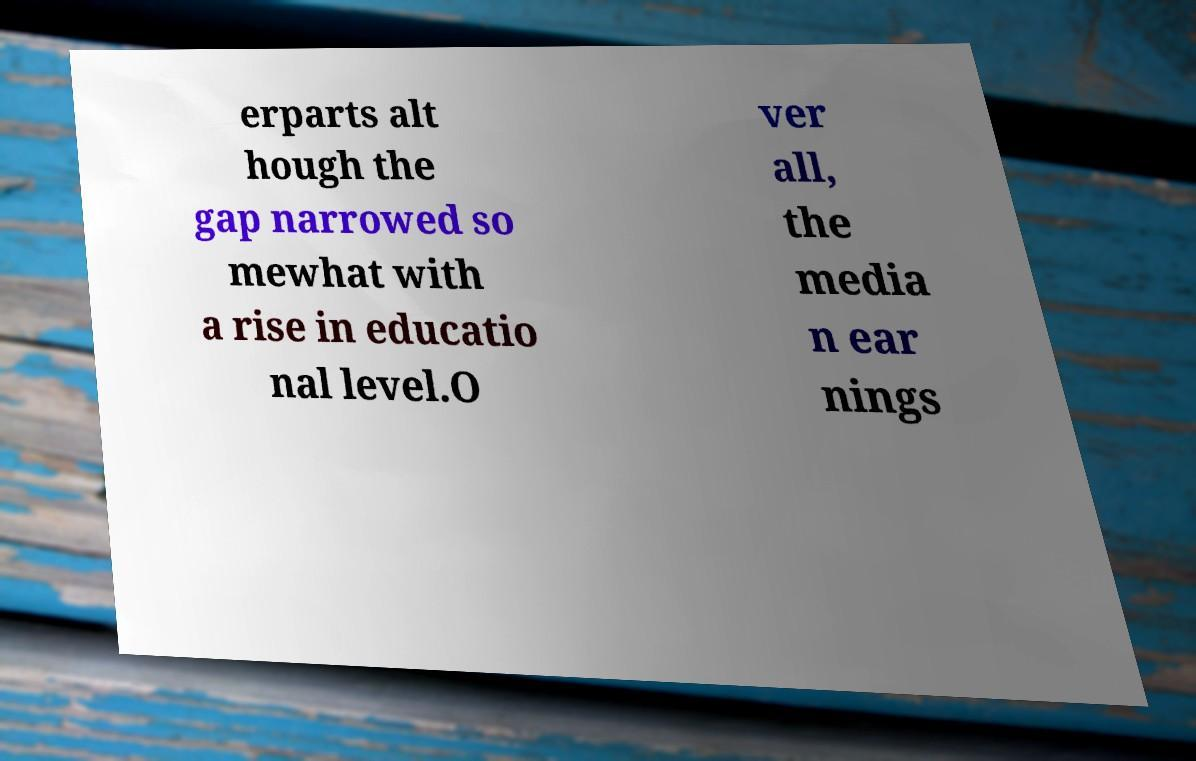Please identify and transcribe the text found in this image. erparts alt hough the gap narrowed so mewhat with a rise in educatio nal level.O ver all, the media n ear nings 